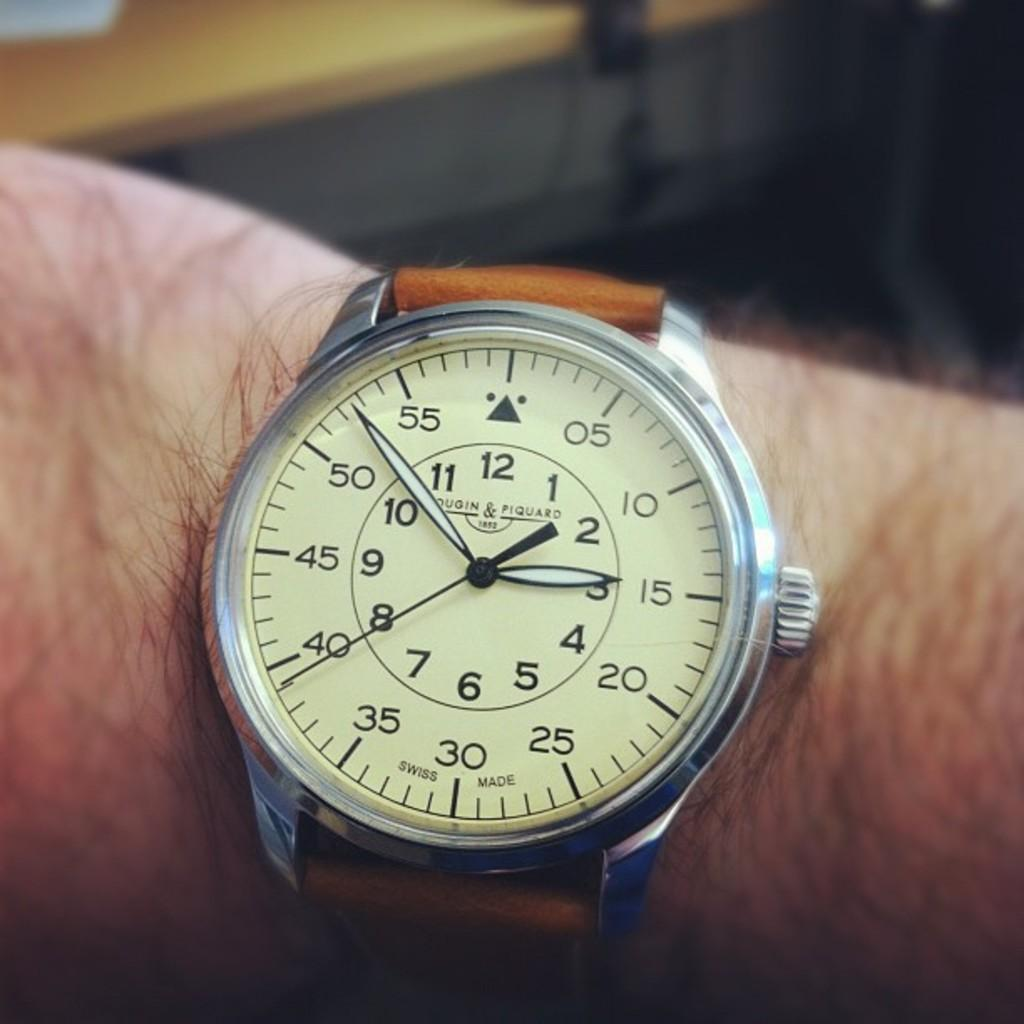What object is visible on a hand in the image? There is a wrist watch in the image, and it is on a hand. What type of furniture is present in the image? There is a table in the image. What page is the snail turning in the image? There is no snail or page present in the image. 